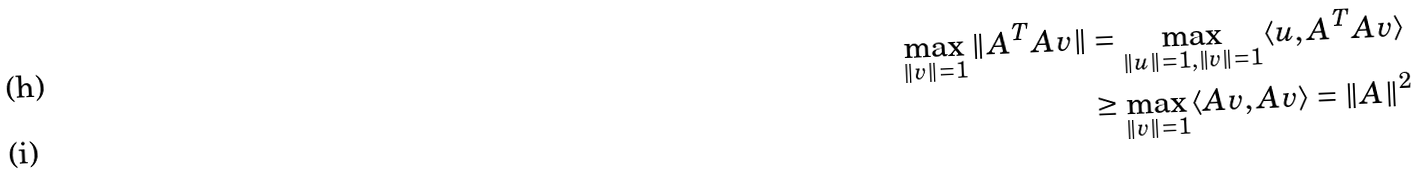<formula> <loc_0><loc_0><loc_500><loc_500>\max _ { \| v \| = 1 } \| A ^ { T } A v \| & = \max _ { \| u \| = 1 , \| v \| = 1 } \langle u , A ^ { T } A v \rangle \\ & \geq \max _ { \| v \| = 1 } \langle A v , A v \rangle = \| A \| ^ { 2 }</formula> 